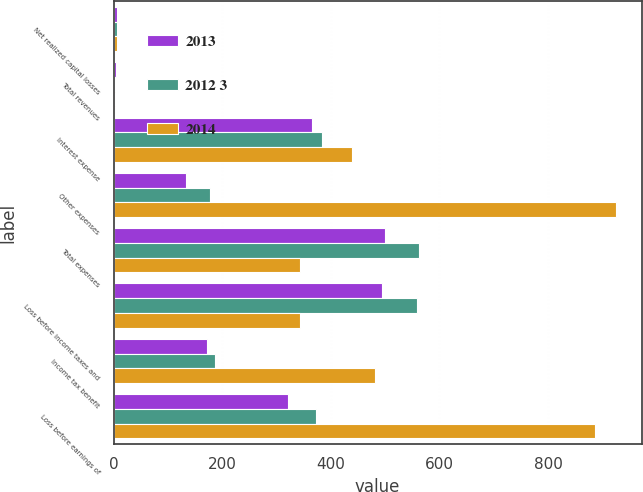Convert chart. <chart><loc_0><loc_0><loc_500><loc_500><stacked_bar_chart><ecel><fcel>Net realized capital losses<fcel>Total revenues<fcel>Interest expense<fcel>Other expenses<fcel>Total expenses<fcel>Loss before income taxes and<fcel>Income tax benefit<fcel>Loss before earnings of<nl><fcel>2013<fcel>6<fcel>5<fcel>365<fcel>134<fcel>499<fcel>494<fcel>172<fcel>322<nl><fcel>2012 3<fcel>7<fcel>3<fcel>384<fcel>178<fcel>562<fcel>559<fcel>187<fcel>372<nl><fcel>2014<fcel>6<fcel>3<fcel>439<fcel>926<fcel>343.5<fcel>343.5<fcel>482<fcel>886<nl></chart> 